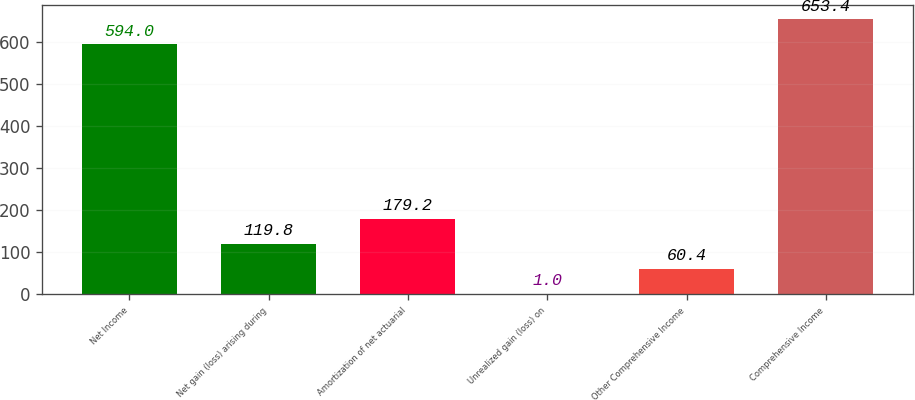Convert chart to OTSL. <chart><loc_0><loc_0><loc_500><loc_500><bar_chart><fcel>Net Income<fcel>Net gain (loss) arising during<fcel>Amortization of net actuarial<fcel>Unrealized gain (loss) on<fcel>Other Comprehensive Income<fcel>Comprehensive Income<nl><fcel>594<fcel>119.8<fcel>179.2<fcel>1<fcel>60.4<fcel>653.4<nl></chart> 